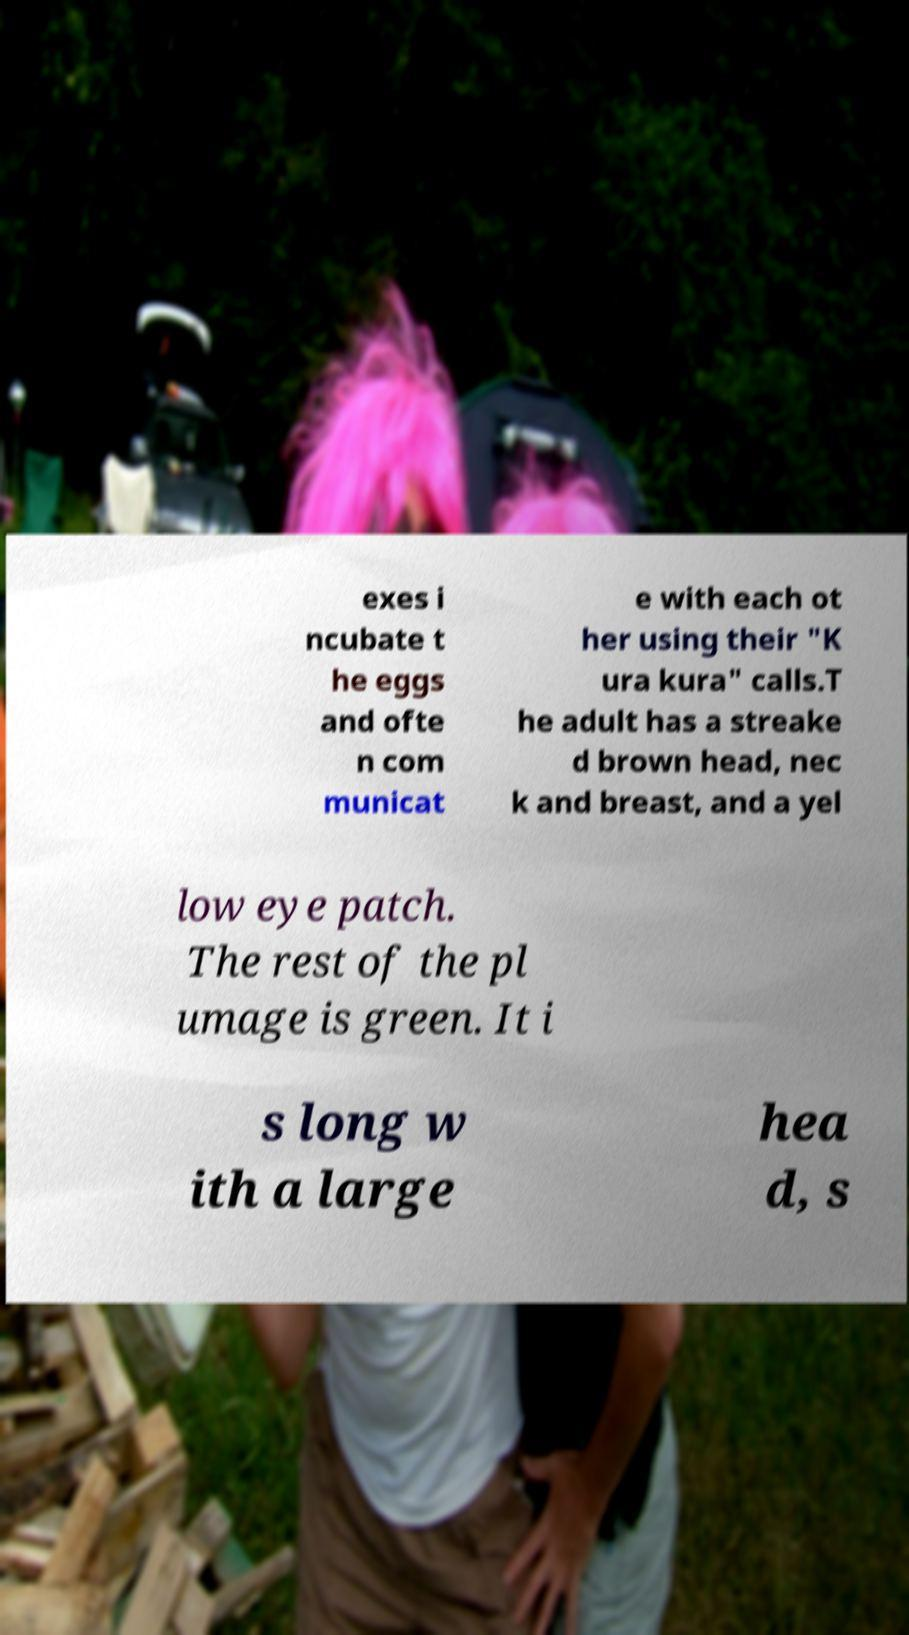Please read and relay the text visible in this image. What does it say? exes i ncubate t he eggs and ofte n com municat e with each ot her using their "K ura kura" calls.T he adult has a streake d brown head, nec k and breast, and a yel low eye patch. The rest of the pl umage is green. It i s long w ith a large hea d, s 